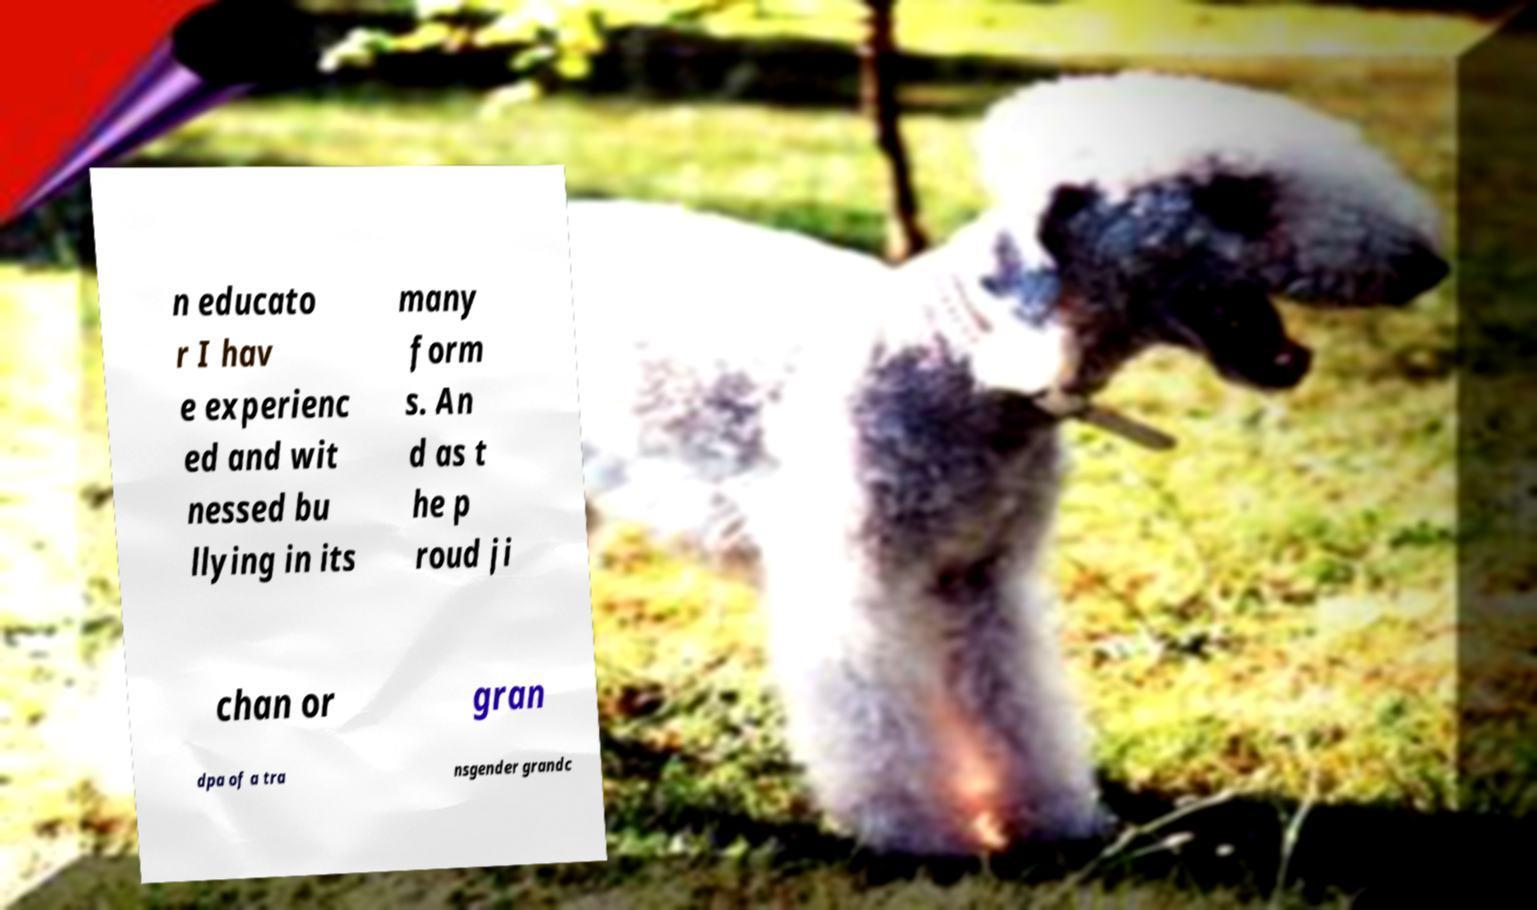I need the written content from this picture converted into text. Can you do that? n educato r I hav e experienc ed and wit nessed bu llying in its many form s. An d as t he p roud ji chan or gran dpa of a tra nsgender grandc 